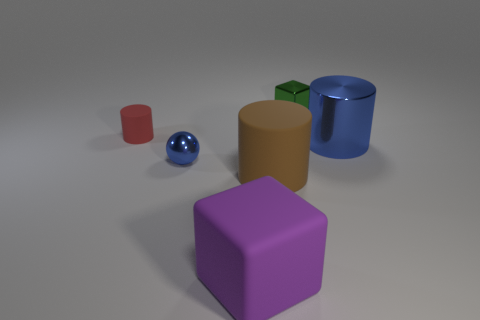Is there anything else of the same color as the large shiny cylinder?
Your answer should be compact. Yes. What is the shape of the big object that is the same color as the tiny metal ball?
Offer a very short reply. Cylinder. Is the number of metallic blocks in front of the big rubber cylinder less than the number of tiny cylinders that are in front of the big purple thing?
Offer a terse response. No. The thing that is both to the right of the sphere and behind the big blue cylinder is made of what material?
Make the answer very short. Metal. Is the shiny cylinder the same color as the shiny ball?
Your response must be concise. Yes. What is the size of the green metallic object that is the same shape as the purple rubber thing?
Provide a succinct answer. Small. How many small green shiny objects are the same shape as the purple rubber thing?
Provide a short and direct response. 1. What number of metal objects are the same color as the big cube?
Give a very brief answer. 0. There is a tiny metallic object that is behind the tiny ball; is its shape the same as the matte thing behind the big metallic object?
Offer a terse response. No. What number of things are right of the cylinder that is behind the blue metallic object on the right side of the purple matte block?
Give a very brief answer. 5. 